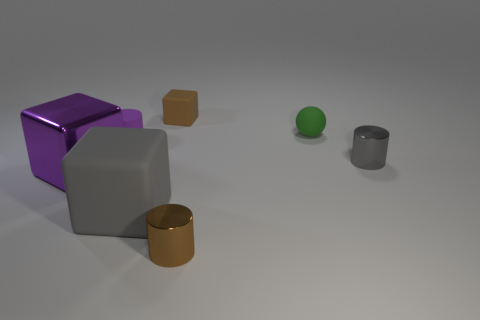Add 2 tiny yellow matte spheres. How many objects exist? 9 Subtract all cubes. How many objects are left? 4 Add 6 small blocks. How many small blocks are left? 7 Add 1 tiny red objects. How many tiny red objects exist? 1 Subtract 0 blue cylinders. How many objects are left? 7 Subtract all cubes. Subtract all tiny green rubber spheres. How many objects are left? 3 